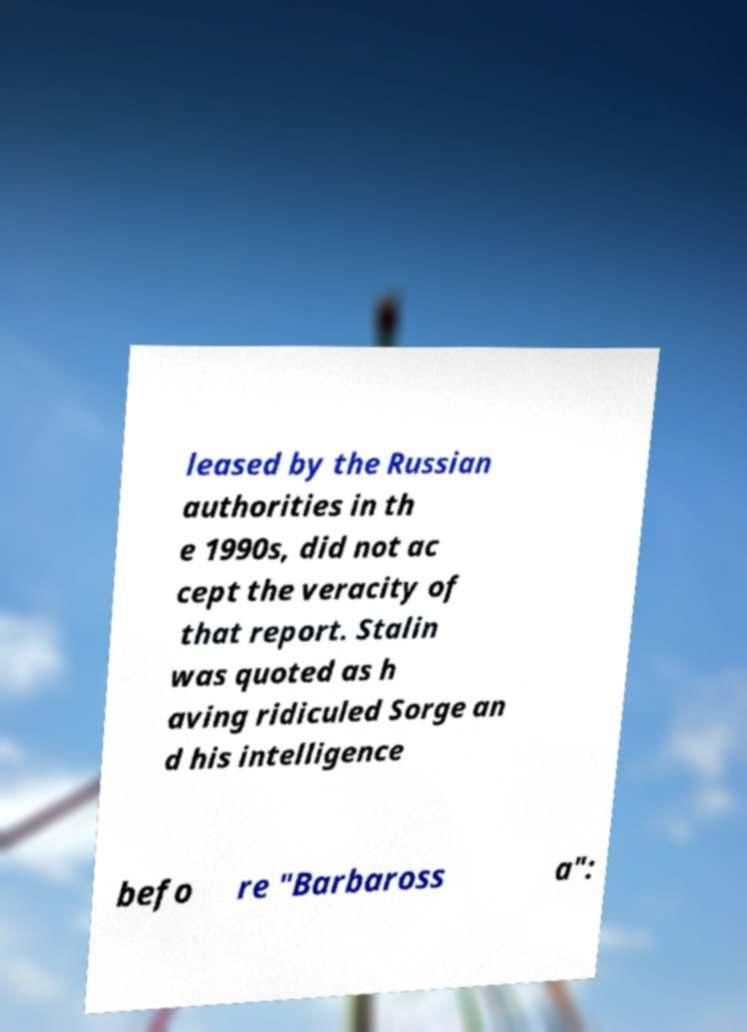For documentation purposes, I need the text within this image transcribed. Could you provide that? leased by the Russian authorities in th e 1990s, did not ac cept the veracity of that report. Stalin was quoted as h aving ridiculed Sorge an d his intelligence befo re "Barbaross a": 